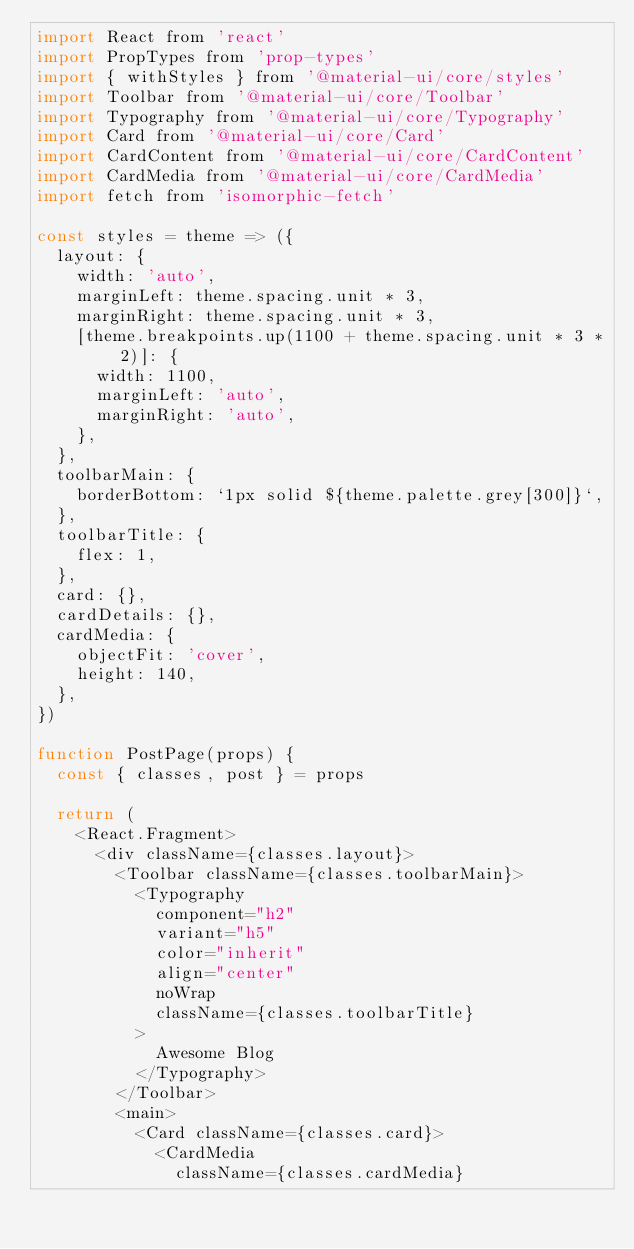<code> <loc_0><loc_0><loc_500><loc_500><_JavaScript_>import React from 'react'
import PropTypes from 'prop-types'
import { withStyles } from '@material-ui/core/styles'
import Toolbar from '@material-ui/core/Toolbar'
import Typography from '@material-ui/core/Typography'
import Card from '@material-ui/core/Card'
import CardContent from '@material-ui/core/CardContent'
import CardMedia from '@material-ui/core/CardMedia'
import fetch from 'isomorphic-fetch'

const styles = theme => ({
  layout: {
    width: 'auto',
    marginLeft: theme.spacing.unit * 3,
    marginRight: theme.spacing.unit * 3,
    [theme.breakpoints.up(1100 + theme.spacing.unit * 3 * 2)]: {
      width: 1100,
      marginLeft: 'auto',
      marginRight: 'auto',
    },
  },
  toolbarMain: {
    borderBottom: `1px solid ${theme.palette.grey[300]}`,
  },
  toolbarTitle: {
    flex: 1,
  },
  card: {},
  cardDetails: {},
  cardMedia: {
    objectFit: 'cover',
    height: 140,
  },
})

function PostPage(props) {
  const { classes, post } = props

  return (
    <React.Fragment>
      <div className={classes.layout}>
        <Toolbar className={classes.toolbarMain}>
          <Typography
            component="h2"
            variant="h5"
            color="inherit"
            align="center"
            noWrap
            className={classes.toolbarTitle}
          >
            Awesome Blog
          </Typography>
        </Toolbar>
        <main>
          <Card className={classes.card}>
            <CardMedia
              className={classes.cardMedia}</code> 